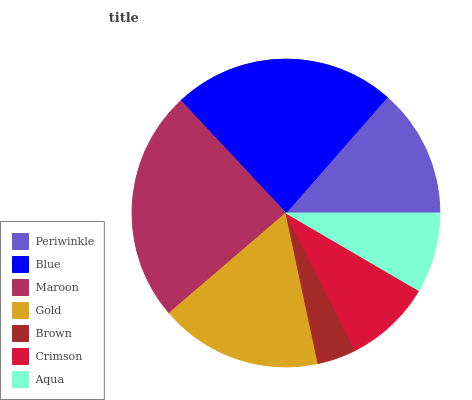Is Brown the minimum?
Answer yes or no. Yes. Is Maroon the maximum?
Answer yes or no. Yes. Is Blue the minimum?
Answer yes or no. No. Is Blue the maximum?
Answer yes or no. No. Is Blue greater than Periwinkle?
Answer yes or no. Yes. Is Periwinkle less than Blue?
Answer yes or no. Yes. Is Periwinkle greater than Blue?
Answer yes or no. No. Is Blue less than Periwinkle?
Answer yes or no. No. Is Periwinkle the high median?
Answer yes or no. Yes. Is Periwinkle the low median?
Answer yes or no. Yes. Is Blue the high median?
Answer yes or no. No. Is Crimson the low median?
Answer yes or no. No. 